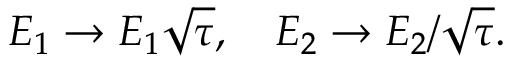Convert formula to latex. <formula><loc_0><loc_0><loc_500><loc_500>E _ { 1 } \rightarrow E _ { 1 } \sqrt { \tau } , \quad E _ { 2 } \rightarrow E _ { 2 } / \sqrt { \tau } .</formula> 